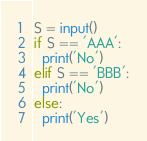<code> <loc_0><loc_0><loc_500><loc_500><_Python_>S = input()
if S == 'AAA':
  print('No')
elif S == 'BBB':
  print('No')
else:
  print('Yes')</code> 